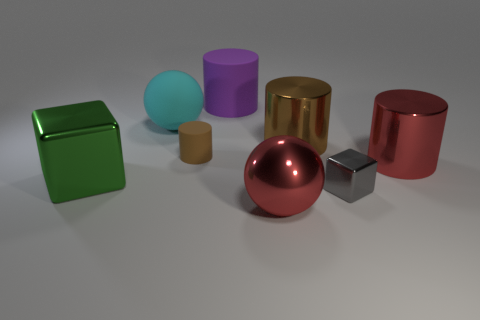Subtract all brown blocks. Subtract all cyan spheres. How many blocks are left? 2 Subtract all purple spheres. How many gray blocks are left? 1 Add 3 big grays. How many things exist? 0 Subtract all brown things. Subtract all large red spheres. How many objects are left? 5 Add 7 small brown rubber cylinders. How many small brown rubber cylinders are left? 8 Add 3 rubber spheres. How many rubber spheres exist? 4 Add 1 large yellow objects. How many objects exist? 9 Subtract all gray blocks. How many blocks are left? 1 Subtract all purple rubber cylinders. How many cylinders are left? 3 Subtract 0 cyan blocks. How many objects are left? 8 